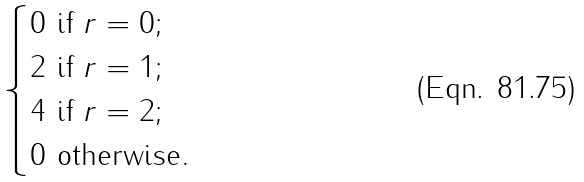<formula> <loc_0><loc_0><loc_500><loc_500>\begin{cases} 0 \text { if } r = 0 ; \\ 2 \text { if } r = 1 ; \\ 4 \text { if } r = 2 ; \\ 0 \text { otherwise} . \end{cases}</formula> 